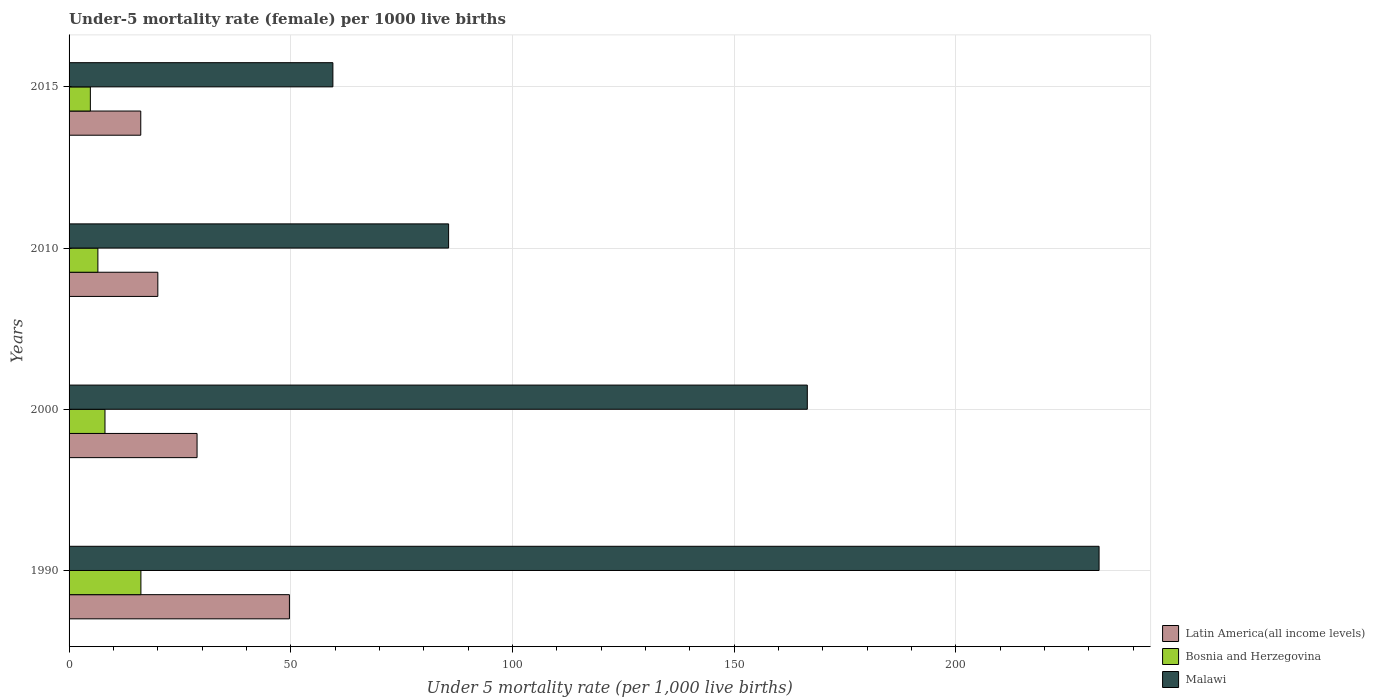How many different coloured bars are there?
Provide a succinct answer. 3. How many groups of bars are there?
Your answer should be very brief. 4. Are the number of bars per tick equal to the number of legend labels?
Provide a succinct answer. Yes. How many bars are there on the 1st tick from the bottom?
Your response must be concise. 3. What is the label of the 1st group of bars from the top?
Your response must be concise. 2015. What is the under-five mortality rate in Latin America(all income levels) in 2010?
Offer a very short reply. 20.02. Across all years, what is the maximum under-five mortality rate in Malawi?
Your answer should be compact. 232.3. Across all years, what is the minimum under-five mortality rate in Latin America(all income levels)?
Offer a very short reply. 16.17. In which year was the under-five mortality rate in Bosnia and Herzegovina maximum?
Provide a succinct answer. 1990. In which year was the under-five mortality rate in Bosnia and Herzegovina minimum?
Your answer should be compact. 2015. What is the total under-five mortality rate in Latin America(all income levels) in the graph?
Your answer should be very brief. 114.75. What is the difference between the under-five mortality rate in Malawi in 1990 and that in 2015?
Ensure brevity in your answer.  172.8. What is the difference between the under-five mortality rate in Bosnia and Herzegovina in 1990 and the under-five mortality rate in Latin America(all income levels) in 2000?
Your answer should be compact. -12.67. What is the average under-five mortality rate in Latin America(all income levels) per year?
Provide a succinct answer. 28.69. In the year 2000, what is the difference between the under-five mortality rate in Latin America(all income levels) and under-five mortality rate in Malawi?
Keep it short and to the point. -137.63. What is the ratio of the under-five mortality rate in Malawi in 1990 to that in 2000?
Give a very brief answer. 1.4. What is the difference between the highest and the second highest under-five mortality rate in Latin America(all income levels)?
Make the answer very short. 20.83. What is the difference between the highest and the lowest under-five mortality rate in Bosnia and Herzegovina?
Offer a very short reply. 11.4. In how many years, is the under-five mortality rate in Bosnia and Herzegovina greater than the average under-five mortality rate in Bosnia and Herzegovina taken over all years?
Provide a short and direct response. 1. Is the sum of the under-five mortality rate in Malawi in 1990 and 2015 greater than the maximum under-five mortality rate in Latin America(all income levels) across all years?
Provide a succinct answer. Yes. What does the 1st bar from the top in 2015 represents?
Give a very brief answer. Malawi. What does the 3rd bar from the bottom in 2010 represents?
Provide a short and direct response. Malawi. How many bars are there?
Your answer should be compact. 12. What is the title of the graph?
Offer a very short reply. Under-5 mortality rate (female) per 1000 live births. What is the label or title of the X-axis?
Offer a terse response. Under 5 mortality rate (per 1,0 live births). What is the Under 5 mortality rate (per 1,000 live births) in Latin America(all income levels) in 1990?
Provide a short and direct response. 49.7. What is the Under 5 mortality rate (per 1,000 live births) in Bosnia and Herzegovina in 1990?
Keep it short and to the point. 16.2. What is the Under 5 mortality rate (per 1,000 live births) of Malawi in 1990?
Your response must be concise. 232.3. What is the Under 5 mortality rate (per 1,000 live births) of Latin America(all income levels) in 2000?
Your answer should be very brief. 28.87. What is the Under 5 mortality rate (per 1,000 live births) in Malawi in 2000?
Your answer should be very brief. 166.5. What is the Under 5 mortality rate (per 1,000 live births) of Latin America(all income levels) in 2010?
Offer a very short reply. 20.02. What is the Under 5 mortality rate (per 1,000 live births) in Bosnia and Herzegovina in 2010?
Your answer should be very brief. 6.5. What is the Under 5 mortality rate (per 1,000 live births) of Malawi in 2010?
Your answer should be compact. 85.6. What is the Under 5 mortality rate (per 1,000 live births) in Latin America(all income levels) in 2015?
Provide a succinct answer. 16.17. What is the Under 5 mortality rate (per 1,000 live births) in Malawi in 2015?
Make the answer very short. 59.5. Across all years, what is the maximum Under 5 mortality rate (per 1,000 live births) in Latin America(all income levels)?
Your response must be concise. 49.7. Across all years, what is the maximum Under 5 mortality rate (per 1,000 live births) of Malawi?
Keep it short and to the point. 232.3. Across all years, what is the minimum Under 5 mortality rate (per 1,000 live births) in Latin America(all income levels)?
Your response must be concise. 16.17. Across all years, what is the minimum Under 5 mortality rate (per 1,000 live births) in Bosnia and Herzegovina?
Your answer should be compact. 4.8. Across all years, what is the minimum Under 5 mortality rate (per 1,000 live births) in Malawi?
Your response must be concise. 59.5. What is the total Under 5 mortality rate (per 1,000 live births) of Latin America(all income levels) in the graph?
Ensure brevity in your answer.  114.75. What is the total Under 5 mortality rate (per 1,000 live births) in Bosnia and Herzegovina in the graph?
Your response must be concise. 35.6. What is the total Under 5 mortality rate (per 1,000 live births) in Malawi in the graph?
Provide a short and direct response. 543.9. What is the difference between the Under 5 mortality rate (per 1,000 live births) in Latin America(all income levels) in 1990 and that in 2000?
Ensure brevity in your answer.  20.83. What is the difference between the Under 5 mortality rate (per 1,000 live births) in Malawi in 1990 and that in 2000?
Give a very brief answer. 65.8. What is the difference between the Under 5 mortality rate (per 1,000 live births) of Latin America(all income levels) in 1990 and that in 2010?
Give a very brief answer. 29.68. What is the difference between the Under 5 mortality rate (per 1,000 live births) in Malawi in 1990 and that in 2010?
Offer a very short reply. 146.7. What is the difference between the Under 5 mortality rate (per 1,000 live births) of Latin America(all income levels) in 1990 and that in 2015?
Provide a short and direct response. 33.53. What is the difference between the Under 5 mortality rate (per 1,000 live births) in Bosnia and Herzegovina in 1990 and that in 2015?
Offer a terse response. 11.4. What is the difference between the Under 5 mortality rate (per 1,000 live births) of Malawi in 1990 and that in 2015?
Provide a succinct answer. 172.8. What is the difference between the Under 5 mortality rate (per 1,000 live births) of Latin America(all income levels) in 2000 and that in 2010?
Your answer should be compact. 8.85. What is the difference between the Under 5 mortality rate (per 1,000 live births) of Bosnia and Herzegovina in 2000 and that in 2010?
Your answer should be compact. 1.6. What is the difference between the Under 5 mortality rate (per 1,000 live births) in Malawi in 2000 and that in 2010?
Make the answer very short. 80.9. What is the difference between the Under 5 mortality rate (per 1,000 live births) in Latin America(all income levels) in 2000 and that in 2015?
Offer a terse response. 12.7. What is the difference between the Under 5 mortality rate (per 1,000 live births) in Bosnia and Herzegovina in 2000 and that in 2015?
Keep it short and to the point. 3.3. What is the difference between the Under 5 mortality rate (per 1,000 live births) of Malawi in 2000 and that in 2015?
Provide a succinct answer. 107. What is the difference between the Under 5 mortality rate (per 1,000 live births) of Latin America(all income levels) in 2010 and that in 2015?
Your response must be concise. 3.85. What is the difference between the Under 5 mortality rate (per 1,000 live births) of Malawi in 2010 and that in 2015?
Provide a succinct answer. 26.1. What is the difference between the Under 5 mortality rate (per 1,000 live births) in Latin America(all income levels) in 1990 and the Under 5 mortality rate (per 1,000 live births) in Bosnia and Herzegovina in 2000?
Ensure brevity in your answer.  41.6. What is the difference between the Under 5 mortality rate (per 1,000 live births) in Latin America(all income levels) in 1990 and the Under 5 mortality rate (per 1,000 live births) in Malawi in 2000?
Your answer should be very brief. -116.8. What is the difference between the Under 5 mortality rate (per 1,000 live births) of Bosnia and Herzegovina in 1990 and the Under 5 mortality rate (per 1,000 live births) of Malawi in 2000?
Your answer should be compact. -150.3. What is the difference between the Under 5 mortality rate (per 1,000 live births) in Latin America(all income levels) in 1990 and the Under 5 mortality rate (per 1,000 live births) in Bosnia and Herzegovina in 2010?
Make the answer very short. 43.2. What is the difference between the Under 5 mortality rate (per 1,000 live births) of Latin America(all income levels) in 1990 and the Under 5 mortality rate (per 1,000 live births) of Malawi in 2010?
Give a very brief answer. -35.9. What is the difference between the Under 5 mortality rate (per 1,000 live births) of Bosnia and Herzegovina in 1990 and the Under 5 mortality rate (per 1,000 live births) of Malawi in 2010?
Your response must be concise. -69.4. What is the difference between the Under 5 mortality rate (per 1,000 live births) in Latin America(all income levels) in 1990 and the Under 5 mortality rate (per 1,000 live births) in Bosnia and Herzegovina in 2015?
Offer a very short reply. 44.9. What is the difference between the Under 5 mortality rate (per 1,000 live births) in Latin America(all income levels) in 1990 and the Under 5 mortality rate (per 1,000 live births) in Malawi in 2015?
Your answer should be compact. -9.8. What is the difference between the Under 5 mortality rate (per 1,000 live births) in Bosnia and Herzegovina in 1990 and the Under 5 mortality rate (per 1,000 live births) in Malawi in 2015?
Provide a short and direct response. -43.3. What is the difference between the Under 5 mortality rate (per 1,000 live births) in Latin America(all income levels) in 2000 and the Under 5 mortality rate (per 1,000 live births) in Bosnia and Herzegovina in 2010?
Give a very brief answer. 22.37. What is the difference between the Under 5 mortality rate (per 1,000 live births) in Latin America(all income levels) in 2000 and the Under 5 mortality rate (per 1,000 live births) in Malawi in 2010?
Ensure brevity in your answer.  -56.73. What is the difference between the Under 5 mortality rate (per 1,000 live births) of Bosnia and Herzegovina in 2000 and the Under 5 mortality rate (per 1,000 live births) of Malawi in 2010?
Your response must be concise. -77.5. What is the difference between the Under 5 mortality rate (per 1,000 live births) of Latin America(all income levels) in 2000 and the Under 5 mortality rate (per 1,000 live births) of Bosnia and Herzegovina in 2015?
Keep it short and to the point. 24.07. What is the difference between the Under 5 mortality rate (per 1,000 live births) in Latin America(all income levels) in 2000 and the Under 5 mortality rate (per 1,000 live births) in Malawi in 2015?
Your answer should be very brief. -30.63. What is the difference between the Under 5 mortality rate (per 1,000 live births) of Bosnia and Herzegovina in 2000 and the Under 5 mortality rate (per 1,000 live births) of Malawi in 2015?
Offer a terse response. -51.4. What is the difference between the Under 5 mortality rate (per 1,000 live births) in Latin America(all income levels) in 2010 and the Under 5 mortality rate (per 1,000 live births) in Bosnia and Herzegovina in 2015?
Your response must be concise. 15.22. What is the difference between the Under 5 mortality rate (per 1,000 live births) in Latin America(all income levels) in 2010 and the Under 5 mortality rate (per 1,000 live births) in Malawi in 2015?
Offer a very short reply. -39.48. What is the difference between the Under 5 mortality rate (per 1,000 live births) of Bosnia and Herzegovina in 2010 and the Under 5 mortality rate (per 1,000 live births) of Malawi in 2015?
Your answer should be compact. -53. What is the average Under 5 mortality rate (per 1,000 live births) in Latin America(all income levels) per year?
Provide a short and direct response. 28.69. What is the average Under 5 mortality rate (per 1,000 live births) in Bosnia and Herzegovina per year?
Your answer should be compact. 8.9. What is the average Under 5 mortality rate (per 1,000 live births) of Malawi per year?
Offer a terse response. 135.97. In the year 1990, what is the difference between the Under 5 mortality rate (per 1,000 live births) in Latin America(all income levels) and Under 5 mortality rate (per 1,000 live births) in Bosnia and Herzegovina?
Make the answer very short. 33.5. In the year 1990, what is the difference between the Under 5 mortality rate (per 1,000 live births) of Latin America(all income levels) and Under 5 mortality rate (per 1,000 live births) of Malawi?
Give a very brief answer. -182.6. In the year 1990, what is the difference between the Under 5 mortality rate (per 1,000 live births) in Bosnia and Herzegovina and Under 5 mortality rate (per 1,000 live births) in Malawi?
Provide a short and direct response. -216.1. In the year 2000, what is the difference between the Under 5 mortality rate (per 1,000 live births) of Latin America(all income levels) and Under 5 mortality rate (per 1,000 live births) of Bosnia and Herzegovina?
Keep it short and to the point. 20.77. In the year 2000, what is the difference between the Under 5 mortality rate (per 1,000 live births) in Latin America(all income levels) and Under 5 mortality rate (per 1,000 live births) in Malawi?
Keep it short and to the point. -137.63. In the year 2000, what is the difference between the Under 5 mortality rate (per 1,000 live births) in Bosnia and Herzegovina and Under 5 mortality rate (per 1,000 live births) in Malawi?
Give a very brief answer. -158.4. In the year 2010, what is the difference between the Under 5 mortality rate (per 1,000 live births) in Latin America(all income levels) and Under 5 mortality rate (per 1,000 live births) in Bosnia and Herzegovina?
Your response must be concise. 13.52. In the year 2010, what is the difference between the Under 5 mortality rate (per 1,000 live births) in Latin America(all income levels) and Under 5 mortality rate (per 1,000 live births) in Malawi?
Ensure brevity in your answer.  -65.58. In the year 2010, what is the difference between the Under 5 mortality rate (per 1,000 live births) of Bosnia and Herzegovina and Under 5 mortality rate (per 1,000 live births) of Malawi?
Ensure brevity in your answer.  -79.1. In the year 2015, what is the difference between the Under 5 mortality rate (per 1,000 live births) of Latin America(all income levels) and Under 5 mortality rate (per 1,000 live births) of Bosnia and Herzegovina?
Give a very brief answer. 11.37. In the year 2015, what is the difference between the Under 5 mortality rate (per 1,000 live births) of Latin America(all income levels) and Under 5 mortality rate (per 1,000 live births) of Malawi?
Your response must be concise. -43.33. In the year 2015, what is the difference between the Under 5 mortality rate (per 1,000 live births) of Bosnia and Herzegovina and Under 5 mortality rate (per 1,000 live births) of Malawi?
Offer a terse response. -54.7. What is the ratio of the Under 5 mortality rate (per 1,000 live births) of Latin America(all income levels) in 1990 to that in 2000?
Make the answer very short. 1.72. What is the ratio of the Under 5 mortality rate (per 1,000 live births) of Bosnia and Herzegovina in 1990 to that in 2000?
Your answer should be very brief. 2. What is the ratio of the Under 5 mortality rate (per 1,000 live births) in Malawi in 1990 to that in 2000?
Your answer should be compact. 1.4. What is the ratio of the Under 5 mortality rate (per 1,000 live births) in Latin America(all income levels) in 1990 to that in 2010?
Offer a very short reply. 2.48. What is the ratio of the Under 5 mortality rate (per 1,000 live births) in Bosnia and Herzegovina in 1990 to that in 2010?
Ensure brevity in your answer.  2.49. What is the ratio of the Under 5 mortality rate (per 1,000 live births) of Malawi in 1990 to that in 2010?
Your answer should be very brief. 2.71. What is the ratio of the Under 5 mortality rate (per 1,000 live births) in Latin America(all income levels) in 1990 to that in 2015?
Your response must be concise. 3.07. What is the ratio of the Under 5 mortality rate (per 1,000 live births) of Bosnia and Herzegovina in 1990 to that in 2015?
Offer a terse response. 3.38. What is the ratio of the Under 5 mortality rate (per 1,000 live births) of Malawi in 1990 to that in 2015?
Provide a short and direct response. 3.9. What is the ratio of the Under 5 mortality rate (per 1,000 live births) in Latin America(all income levels) in 2000 to that in 2010?
Keep it short and to the point. 1.44. What is the ratio of the Under 5 mortality rate (per 1,000 live births) in Bosnia and Herzegovina in 2000 to that in 2010?
Offer a very short reply. 1.25. What is the ratio of the Under 5 mortality rate (per 1,000 live births) of Malawi in 2000 to that in 2010?
Your response must be concise. 1.95. What is the ratio of the Under 5 mortality rate (per 1,000 live births) in Latin America(all income levels) in 2000 to that in 2015?
Provide a short and direct response. 1.79. What is the ratio of the Under 5 mortality rate (per 1,000 live births) in Bosnia and Herzegovina in 2000 to that in 2015?
Offer a terse response. 1.69. What is the ratio of the Under 5 mortality rate (per 1,000 live births) in Malawi in 2000 to that in 2015?
Make the answer very short. 2.8. What is the ratio of the Under 5 mortality rate (per 1,000 live births) of Latin America(all income levels) in 2010 to that in 2015?
Your answer should be very brief. 1.24. What is the ratio of the Under 5 mortality rate (per 1,000 live births) in Bosnia and Herzegovina in 2010 to that in 2015?
Your answer should be very brief. 1.35. What is the ratio of the Under 5 mortality rate (per 1,000 live births) of Malawi in 2010 to that in 2015?
Provide a succinct answer. 1.44. What is the difference between the highest and the second highest Under 5 mortality rate (per 1,000 live births) of Latin America(all income levels)?
Offer a very short reply. 20.83. What is the difference between the highest and the second highest Under 5 mortality rate (per 1,000 live births) of Malawi?
Offer a very short reply. 65.8. What is the difference between the highest and the lowest Under 5 mortality rate (per 1,000 live births) of Latin America(all income levels)?
Your answer should be compact. 33.53. What is the difference between the highest and the lowest Under 5 mortality rate (per 1,000 live births) in Bosnia and Herzegovina?
Offer a very short reply. 11.4. What is the difference between the highest and the lowest Under 5 mortality rate (per 1,000 live births) of Malawi?
Your answer should be very brief. 172.8. 